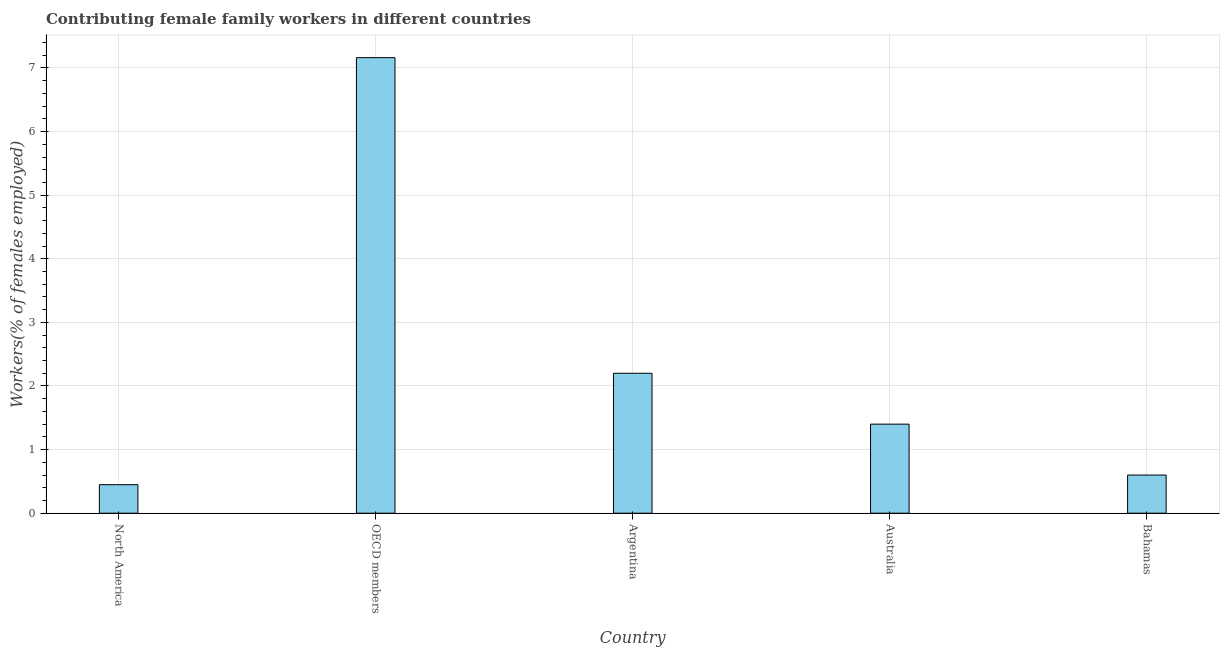Does the graph contain any zero values?
Make the answer very short. No. What is the title of the graph?
Provide a succinct answer. Contributing female family workers in different countries. What is the label or title of the Y-axis?
Provide a short and direct response. Workers(% of females employed). What is the contributing female family workers in Australia?
Keep it short and to the point. 1.4. Across all countries, what is the maximum contributing female family workers?
Make the answer very short. 7.16. Across all countries, what is the minimum contributing female family workers?
Provide a succinct answer. 0.45. In which country was the contributing female family workers minimum?
Your response must be concise. North America. What is the sum of the contributing female family workers?
Keep it short and to the point. 11.81. What is the difference between the contributing female family workers in Australia and OECD members?
Make the answer very short. -5.76. What is the average contributing female family workers per country?
Make the answer very short. 2.36. What is the median contributing female family workers?
Provide a short and direct response. 1.4. What is the ratio of the contributing female family workers in Australia to that in Bahamas?
Offer a very short reply. 2.33. Is the contributing female family workers in Australia less than that in OECD members?
Provide a short and direct response. Yes. Is the difference between the contributing female family workers in Australia and Bahamas greater than the difference between any two countries?
Make the answer very short. No. What is the difference between the highest and the second highest contributing female family workers?
Offer a terse response. 4.96. What is the difference between the highest and the lowest contributing female family workers?
Your response must be concise. 6.71. In how many countries, is the contributing female family workers greater than the average contributing female family workers taken over all countries?
Keep it short and to the point. 1. How many bars are there?
Your response must be concise. 5. Are all the bars in the graph horizontal?
Offer a very short reply. No. How many countries are there in the graph?
Give a very brief answer. 5. What is the difference between two consecutive major ticks on the Y-axis?
Keep it short and to the point. 1. What is the Workers(% of females employed) in North America?
Your answer should be compact. 0.45. What is the Workers(% of females employed) in OECD members?
Keep it short and to the point. 7.16. What is the Workers(% of females employed) in Argentina?
Your response must be concise. 2.2. What is the Workers(% of females employed) in Australia?
Provide a short and direct response. 1.4. What is the Workers(% of females employed) of Bahamas?
Give a very brief answer. 0.6. What is the difference between the Workers(% of females employed) in North America and OECD members?
Your answer should be very brief. -6.71. What is the difference between the Workers(% of females employed) in North America and Argentina?
Your answer should be compact. -1.75. What is the difference between the Workers(% of females employed) in North America and Australia?
Your answer should be very brief. -0.95. What is the difference between the Workers(% of females employed) in North America and Bahamas?
Offer a very short reply. -0.15. What is the difference between the Workers(% of females employed) in OECD members and Argentina?
Your response must be concise. 4.96. What is the difference between the Workers(% of females employed) in OECD members and Australia?
Your response must be concise. 5.76. What is the difference between the Workers(% of females employed) in OECD members and Bahamas?
Ensure brevity in your answer.  6.56. What is the difference between the Workers(% of females employed) in Argentina and Australia?
Your answer should be compact. 0.8. What is the ratio of the Workers(% of females employed) in North America to that in OECD members?
Your answer should be compact. 0.06. What is the ratio of the Workers(% of females employed) in North America to that in Argentina?
Your response must be concise. 0.2. What is the ratio of the Workers(% of females employed) in North America to that in Australia?
Your answer should be compact. 0.32. What is the ratio of the Workers(% of females employed) in North America to that in Bahamas?
Offer a very short reply. 0.75. What is the ratio of the Workers(% of females employed) in OECD members to that in Argentina?
Give a very brief answer. 3.25. What is the ratio of the Workers(% of females employed) in OECD members to that in Australia?
Make the answer very short. 5.12. What is the ratio of the Workers(% of females employed) in OECD members to that in Bahamas?
Provide a short and direct response. 11.94. What is the ratio of the Workers(% of females employed) in Argentina to that in Australia?
Make the answer very short. 1.57. What is the ratio of the Workers(% of females employed) in Argentina to that in Bahamas?
Offer a terse response. 3.67. What is the ratio of the Workers(% of females employed) in Australia to that in Bahamas?
Make the answer very short. 2.33. 